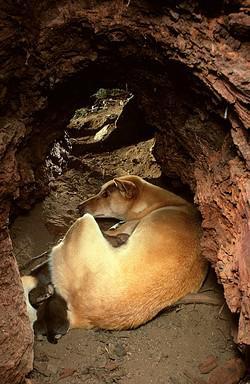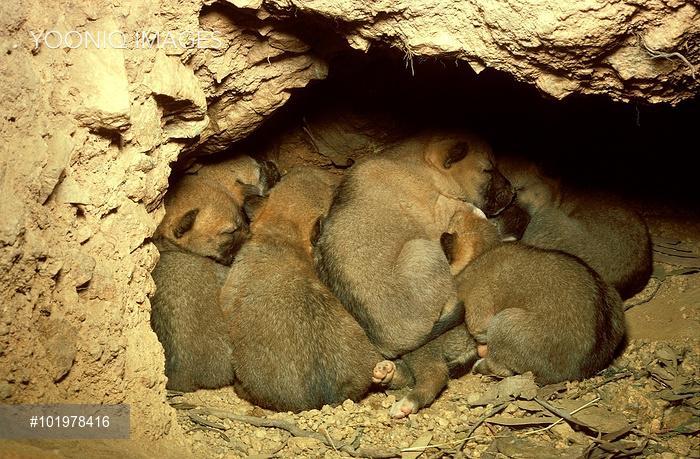The first image is the image on the left, the second image is the image on the right. Given the left and right images, does the statement "In the image on the right several puppies are nestled on straw." hold true? Answer yes or no. No. The first image is the image on the left, the second image is the image on the right. For the images displayed, is the sentence "One image shows only multiple pups, and the other image shows a mother dog with pups." factually correct? Answer yes or no. Yes. 